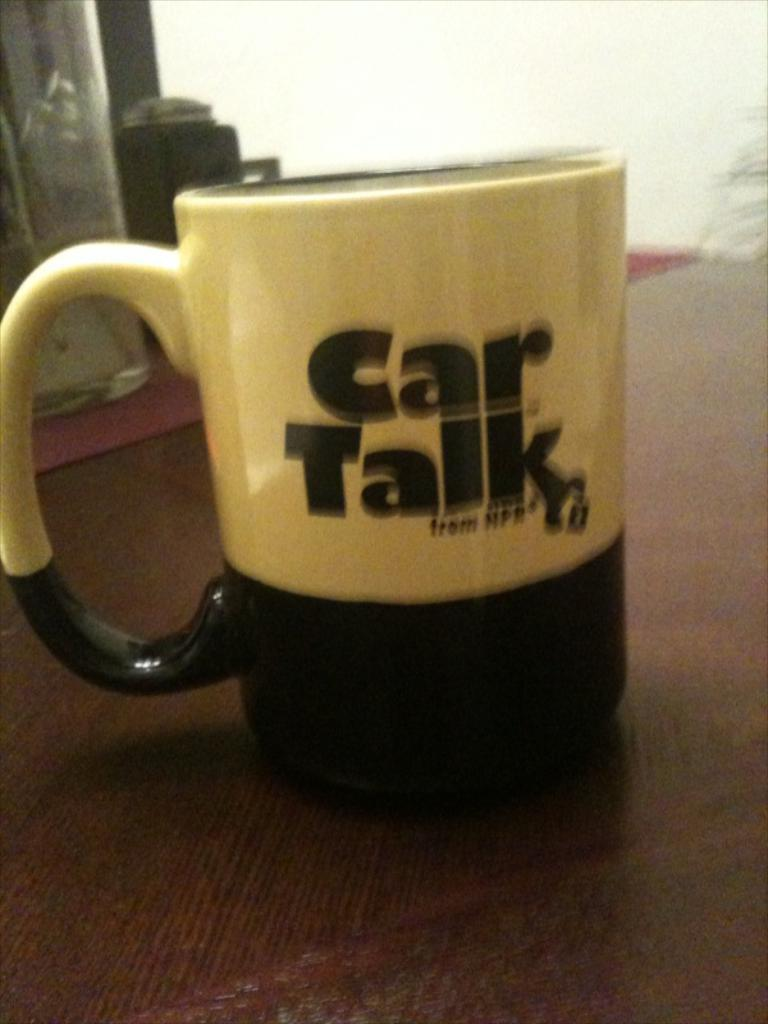<image>
Present a compact description of the photo's key features. The coffee mug is a momento from "Car Talk", a show on NPR. 